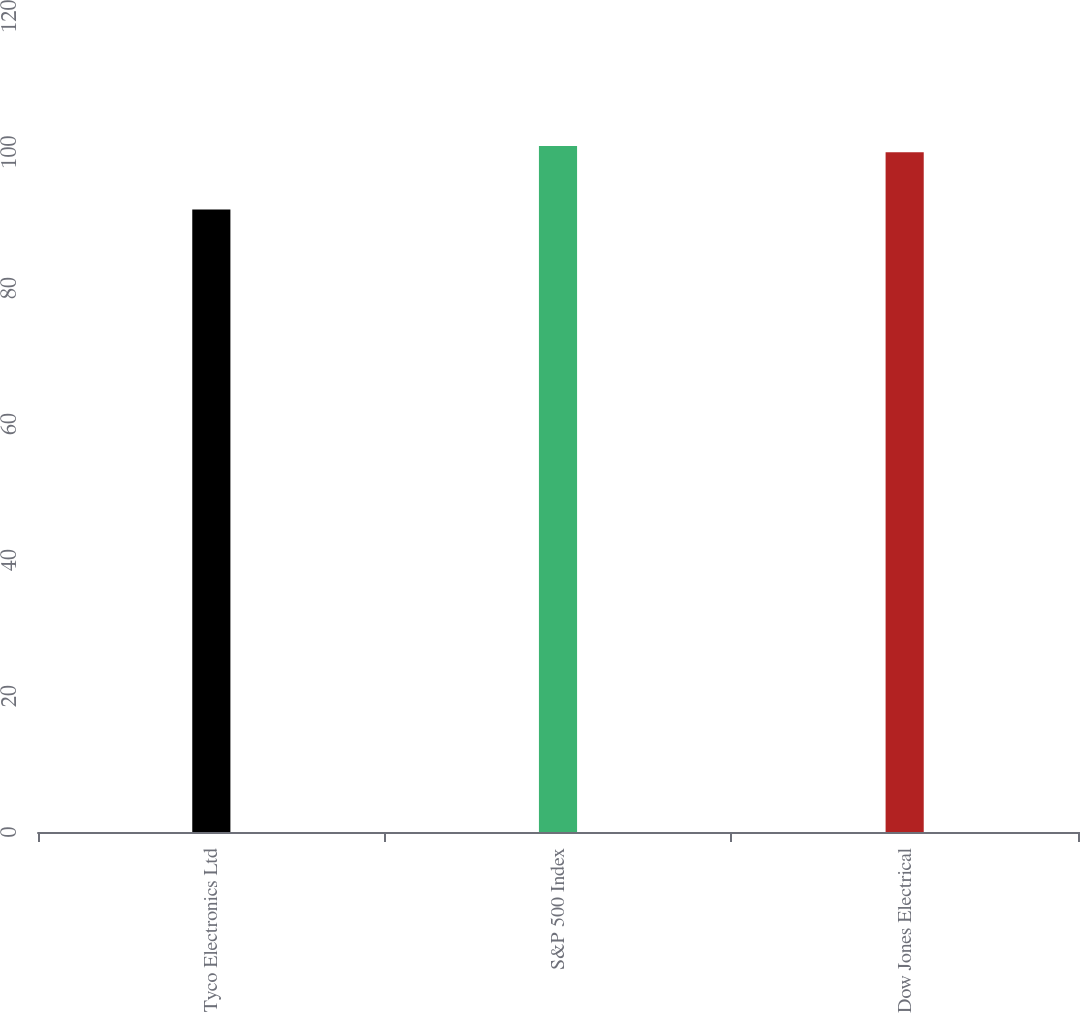Convert chart to OTSL. <chart><loc_0><loc_0><loc_500><loc_500><bar_chart><fcel>Tyco Electronics Ltd<fcel>S&P 500 Index<fcel>Dow Jones Electrical<nl><fcel>91.56<fcel>100.89<fcel>99.97<nl></chart> 